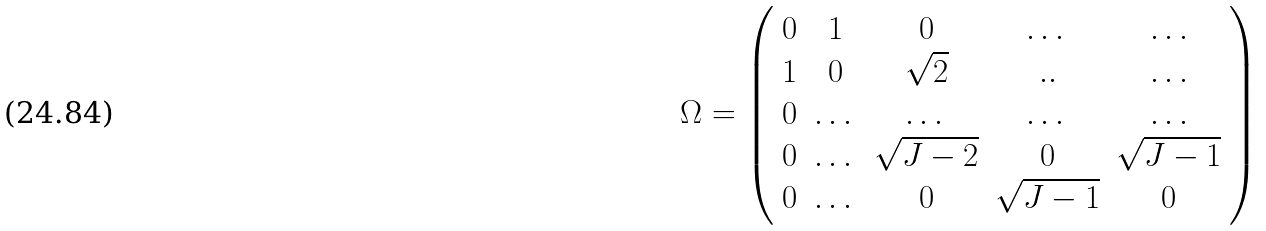<formula> <loc_0><loc_0><loc_500><loc_500>\Omega = \left ( \begin{array} { c c c c c } 0 & 1 & 0 & \dots & \dots \\ 1 & 0 & \sqrt { 2 } & . . & \dots \\ 0 & \dots & \dots & \dots & \dots \\ 0 & \dots & \sqrt { J - 2 } & 0 & \sqrt { J - 1 } \\ 0 & \dots & 0 & \sqrt { J - 1 } & 0 \end{array} \right )</formula> 